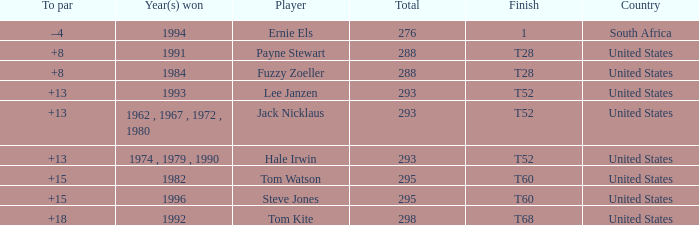What is the average total of player hale irwin, who had a t52 finish? 293.0. 